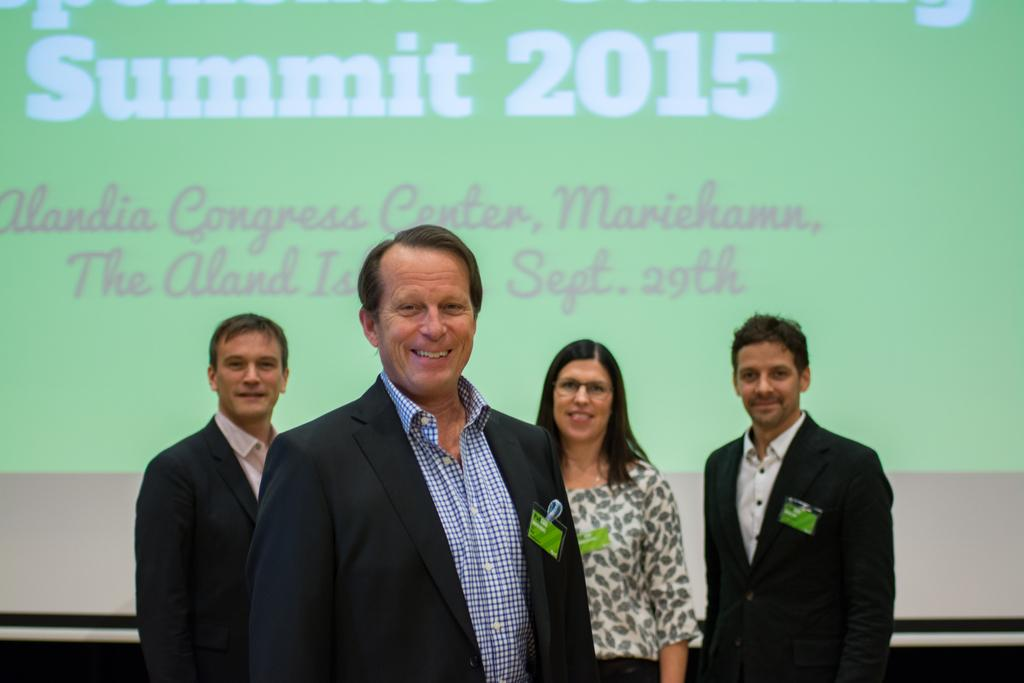What can be seen in the image? There are people standing in the image, and they have their ID cards on their coats. What else is present in the image? There is a projector screen in the image. What is displayed on the projector screen? The projector screen displays the text "Summit 2015". Can you see a trail of force being exerted by the people in the image? There is no trail of force visible in the image; it only shows people standing with their ID cards on their coats and a projector screen displaying "Summit 2015". 